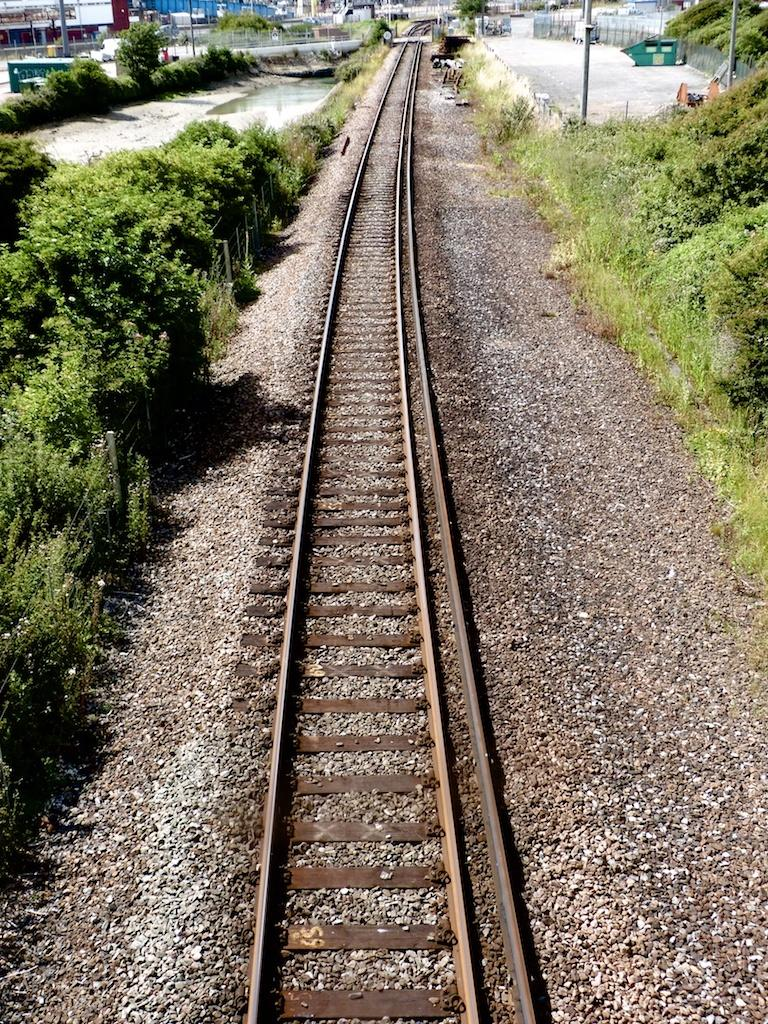What is the main subject in the middle of the image? There is a railway track in the middle of the image. What can be seen on either side of the railway track? There are trees on either side of the railway track. What type of brass instruments are being played by the dolls in the image? There are no brass instruments or dolls present in the image; it only features a railway track and trees. 